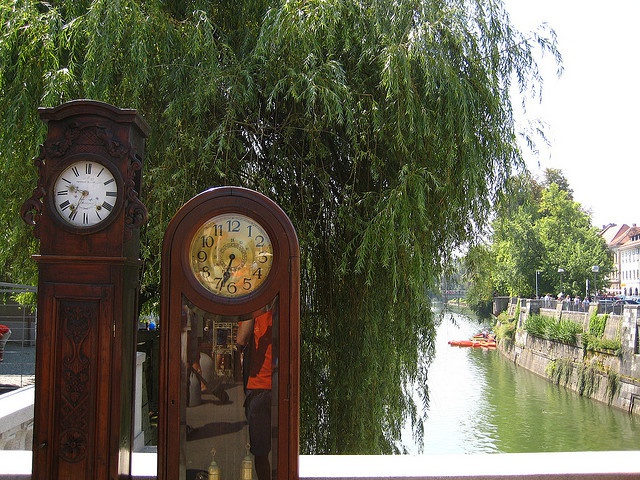Describe the objects in this image and their specific colors. I can see clock in darkgreen, tan, olive, and gray tones, people in darkgreen, black, brown, and maroon tones, and clock in darkgreen, darkgray, gray, and lightgray tones in this image. 